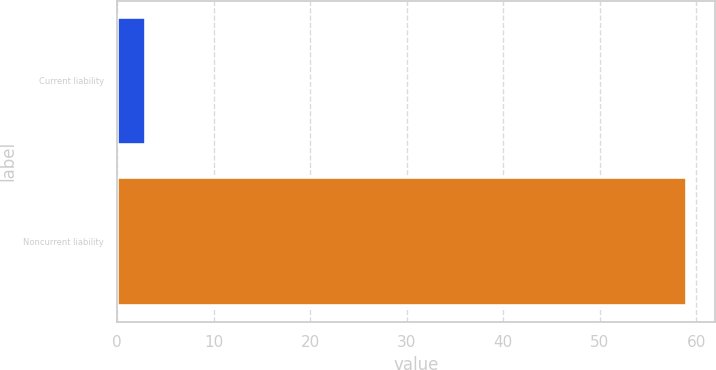Convert chart to OTSL. <chart><loc_0><loc_0><loc_500><loc_500><bar_chart><fcel>Current liability<fcel>Noncurrent liability<nl><fcel>3<fcel>59<nl></chart> 